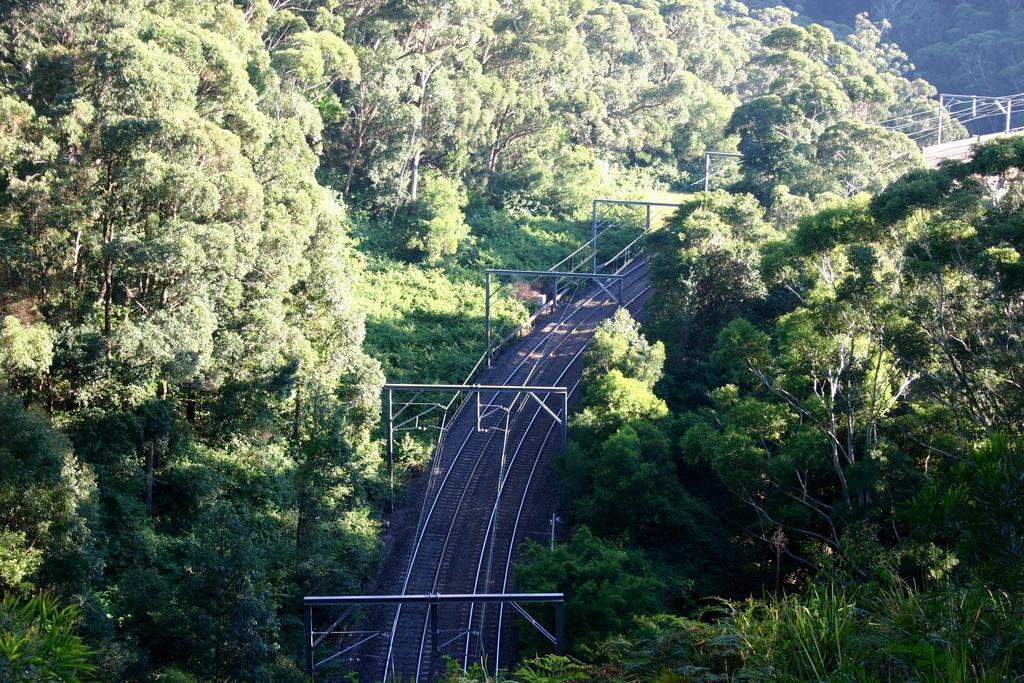Can you describe this image briefly? In this image, we can see a railway track and some poles above the track. On the left and right side, we can see trees that are green in color. 